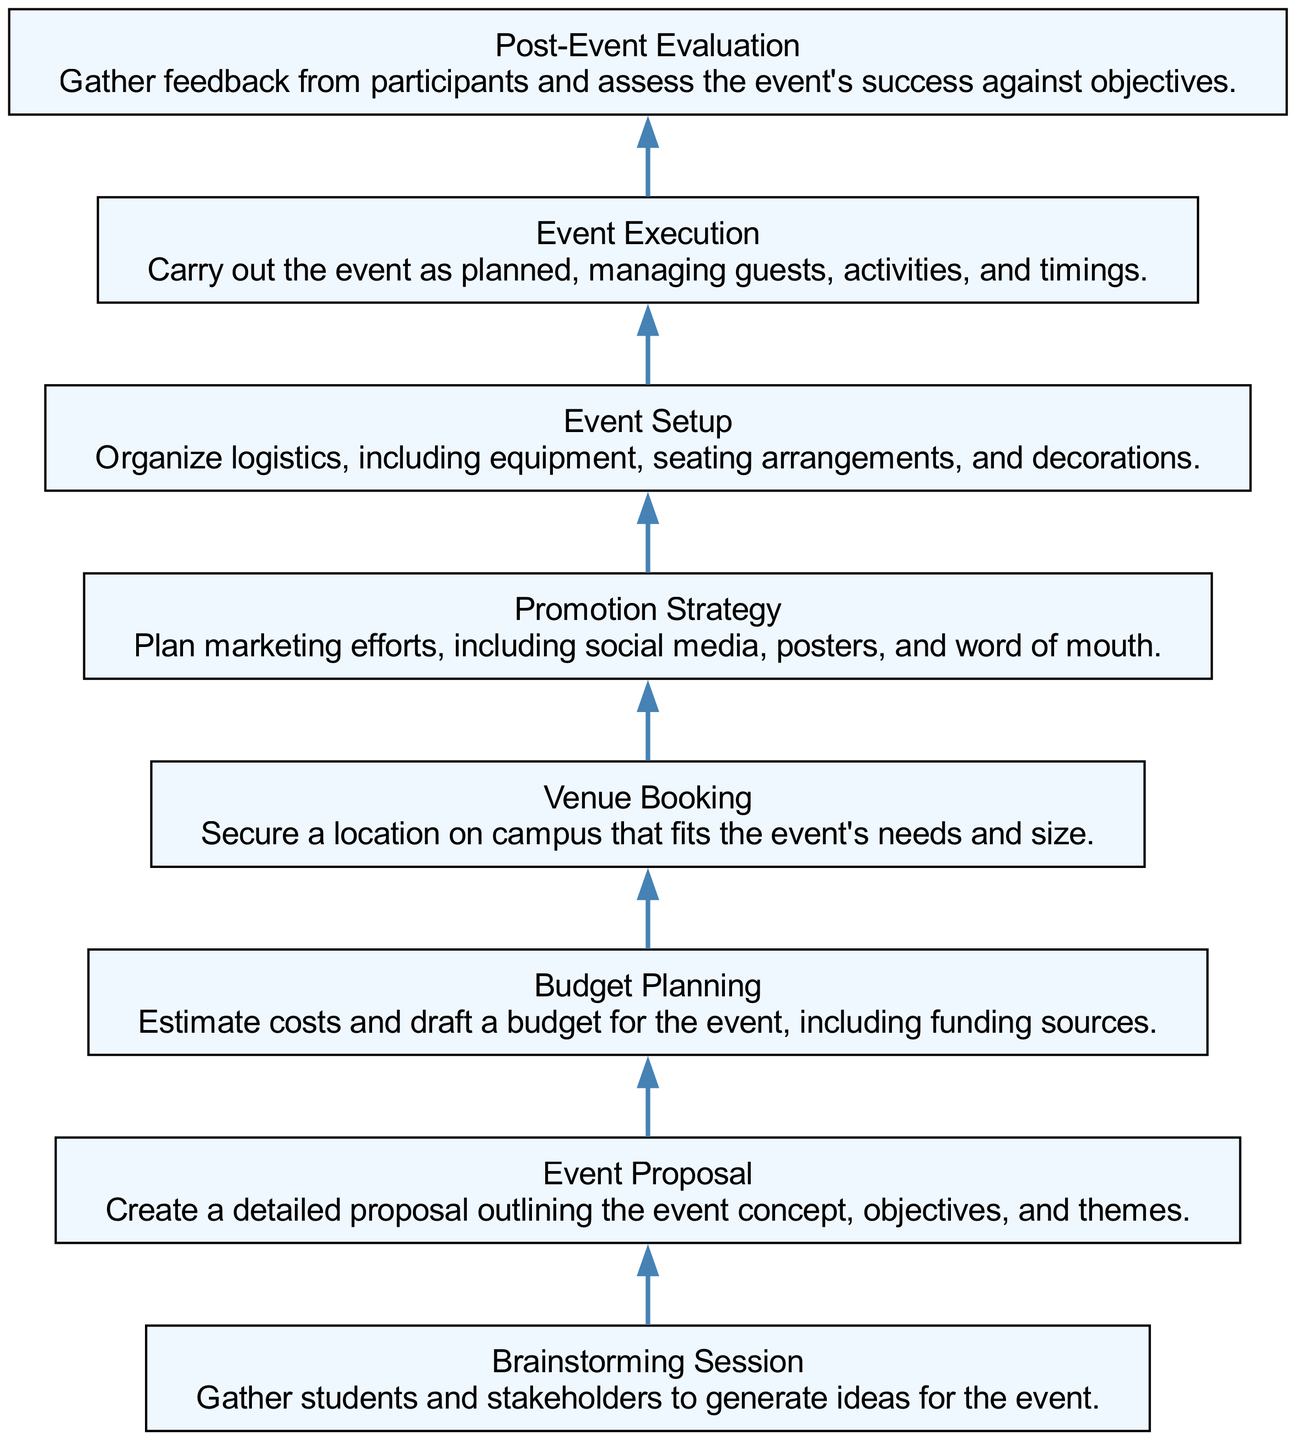What is the first step in the event organization process? The first step is "Brainstorming Session." This node is located at the bottom of the flow chart as the starting point and indicates the initial gathering of ideas.
Answer: Brainstorming Session How many total nodes are in the diagram? The diagram contains a total of 8 nodes, each representing a step in the event organization process, connected from the bottom to the top.
Answer: 8 What is the goal of the "Post-Event Evaluation"? The goal is to "gather feedback from participants and assess the event's success against objectives," as described in the node's text.
Answer: Gather feedback What step follows "Venue Booking"? "Promotion Strategy" follows "Venue Booking" in the flow of the diagram, indicating it is the next necessary step after securing the event location.
Answer: Promotion Strategy What is required for "Budget Planning"? "Estimate costs and draft a budget for the event, including funding sources" is required as stated in the description within the node for "Budget Planning."
Answer: Estimate costs Why is "Event Execution" crucial in the process? "Event Execution" is crucial because it carries out the event as planned, managing guests, activities, and timings, which are vital for the event's success.
Answer: Manages execution Which two nodes are adjacent to "Event Setup"? "Promotion Strategy" and "Event Execution" are adjacent to "Event Setup," as "Event Setup" is placed between these two steps in the flow chart.
Answer: Promotion Strategy and Event Execution What is the primary focus of the "Promotion Strategy"? The primary focus is to "plan marketing efforts, including social media, posters, and word of mouth," highlighting the need to generate interest in the event.
Answer: Plan marketing efforts 